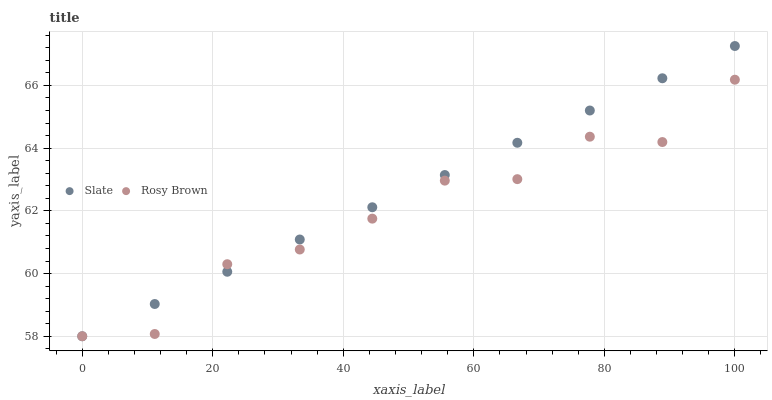Does Rosy Brown have the minimum area under the curve?
Answer yes or no. Yes. Does Slate have the maximum area under the curve?
Answer yes or no. Yes. Does Rosy Brown have the maximum area under the curve?
Answer yes or no. No. Is Slate the smoothest?
Answer yes or no. Yes. Is Rosy Brown the roughest?
Answer yes or no. Yes. Is Rosy Brown the smoothest?
Answer yes or no. No. Does Slate have the lowest value?
Answer yes or no. Yes. Does Slate have the highest value?
Answer yes or no. Yes. Does Rosy Brown have the highest value?
Answer yes or no. No. Does Rosy Brown intersect Slate?
Answer yes or no. Yes. Is Rosy Brown less than Slate?
Answer yes or no. No. Is Rosy Brown greater than Slate?
Answer yes or no. No. 